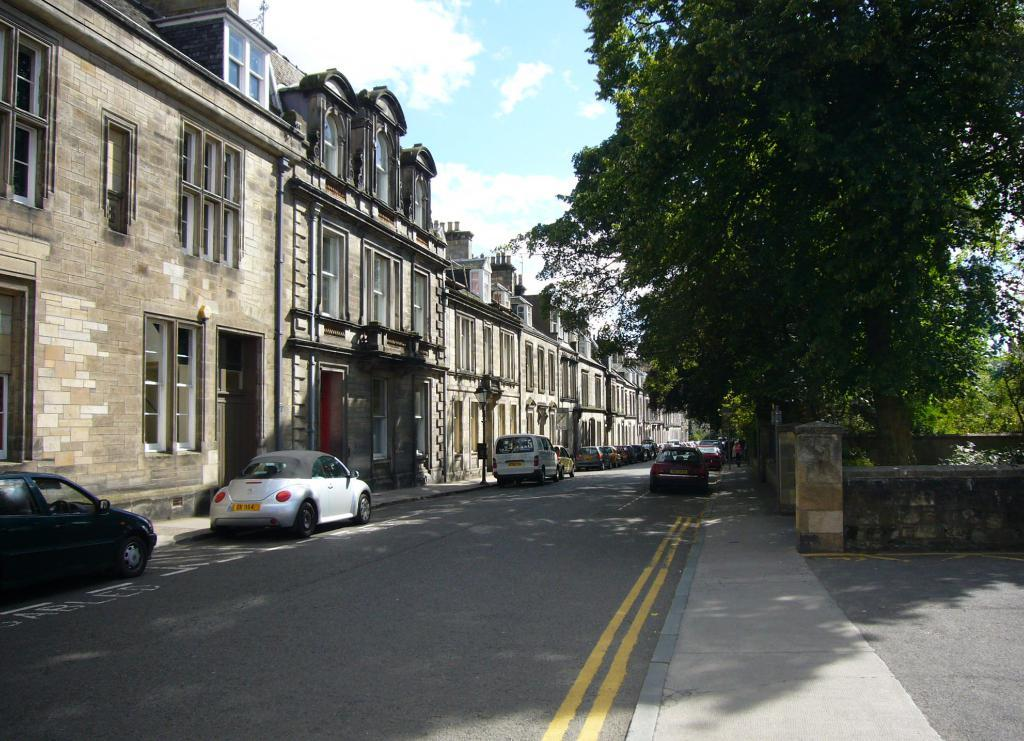What structures are located on the left side of the image? There are buildings on the left side of the image. What else can be seen on the left side of the image? There are cars on the left side of the image. What feature do the buildings have? The buildings have many windows. What type of vegetation is visible in the top right side of the image? There are trees in the top right side of the image. What type of cart is being pulled by the quarter in the image? There is no cart or quarter present in the image. What kind of cloud can be seen in the image? There is no cloud visible in the image; it only features buildings, cars, and trees. 